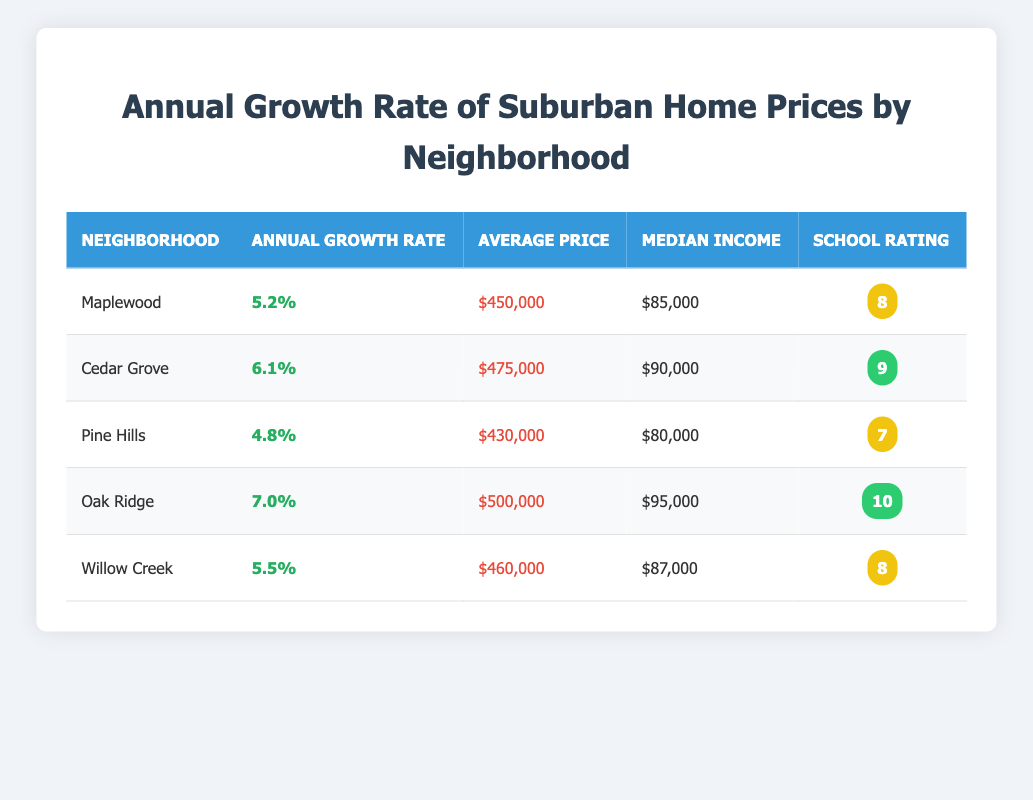What is the highest annual growth rate among the neighborhoods? By examining the "Annual Growth Rate" column, Oak Ridge shows the highest percentage at 7.0%.
Answer: 7.0% What is the average price of homes in Willow Creek? From the "Average Price" column, the price listed for Willow Creek is $460,000.
Answer: $460,000 Which neighborhood has the highest school rating? Looking at the "School Rating" column, Oak Ridge has the highest school rating of 10.
Answer: 10 What is the difference in average price between Oak Ridge and Pine Hills? Oak Ridge has an average price of $500,000, while Pine Hills has an average price of $430,000. The difference is $500,000 - $430,000 = $70,000.
Answer: $70,000 Are the median incomes in Maplewood and Cedar Grove both above $85,000? Maplewood has a median income of $85,000, while Cedar Grove has $90,000, so both are above $85,000.
Answer: Yes What is the average annual growth rate for all neighborhoods listed? To calculate the average, sum up the growth rates (5.2 + 6.1 + 4.8 + 7.0 + 5.5 = 28.6) and divide by the number of neighborhoods (5). Therefore, 28.6 / 5 = 5.72%.
Answer: 5.72% Which neighborhood has a lower average price: Pine Hills or Maplewood? Pine Hills has an average price of $430,000, whereas Maplewood’s average price is $450,000; hence Pine Hills is lower.
Answer: Pine Hills Is the average price in Cedar Grove greater than the median income in Pine Hills? Cedar Grove's average price is $475,000, and the median income in Pine Hills is $80,000. Since $475,000 is greater than $80,000, the statement is true.
Answer: Yes Which neighborhood has the same school rating as Maplewood? Maplewood has a school rating of 8, and Willow Creek also has a rating of 8, making them the same.
Answer: Willow Creek 